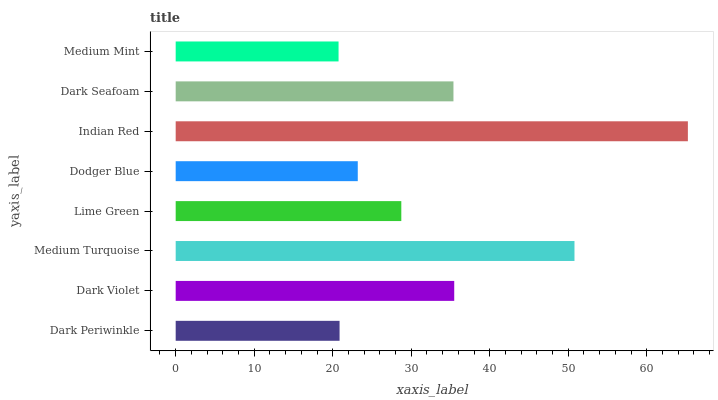Is Medium Mint the minimum?
Answer yes or no. Yes. Is Indian Red the maximum?
Answer yes or no. Yes. Is Dark Violet the minimum?
Answer yes or no. No. Is Dark Violet the maximum?
Answer yes or no. No. Is Dark Violet greater than Dark Periwinkle?
Answer yes or no. Yes. Is Dark Periwinkle less than Dark Violet?
Answer yes or no. Yes. Is Dark Periwinkle greater than Dark Violet?
Answer yes or no. No. Is Dark Violet less than Dark Periwinkle?
Answer yes or no. No. Is Dark Seafoam the high median?
Answer yes or no. Yes. Is Lime Green the low median?
Answer yes or no. Yes. Is Indian Red the high median?
Answer yes or no. No. Is Dark Seafoam the low median?
Answer yes or no. No. 